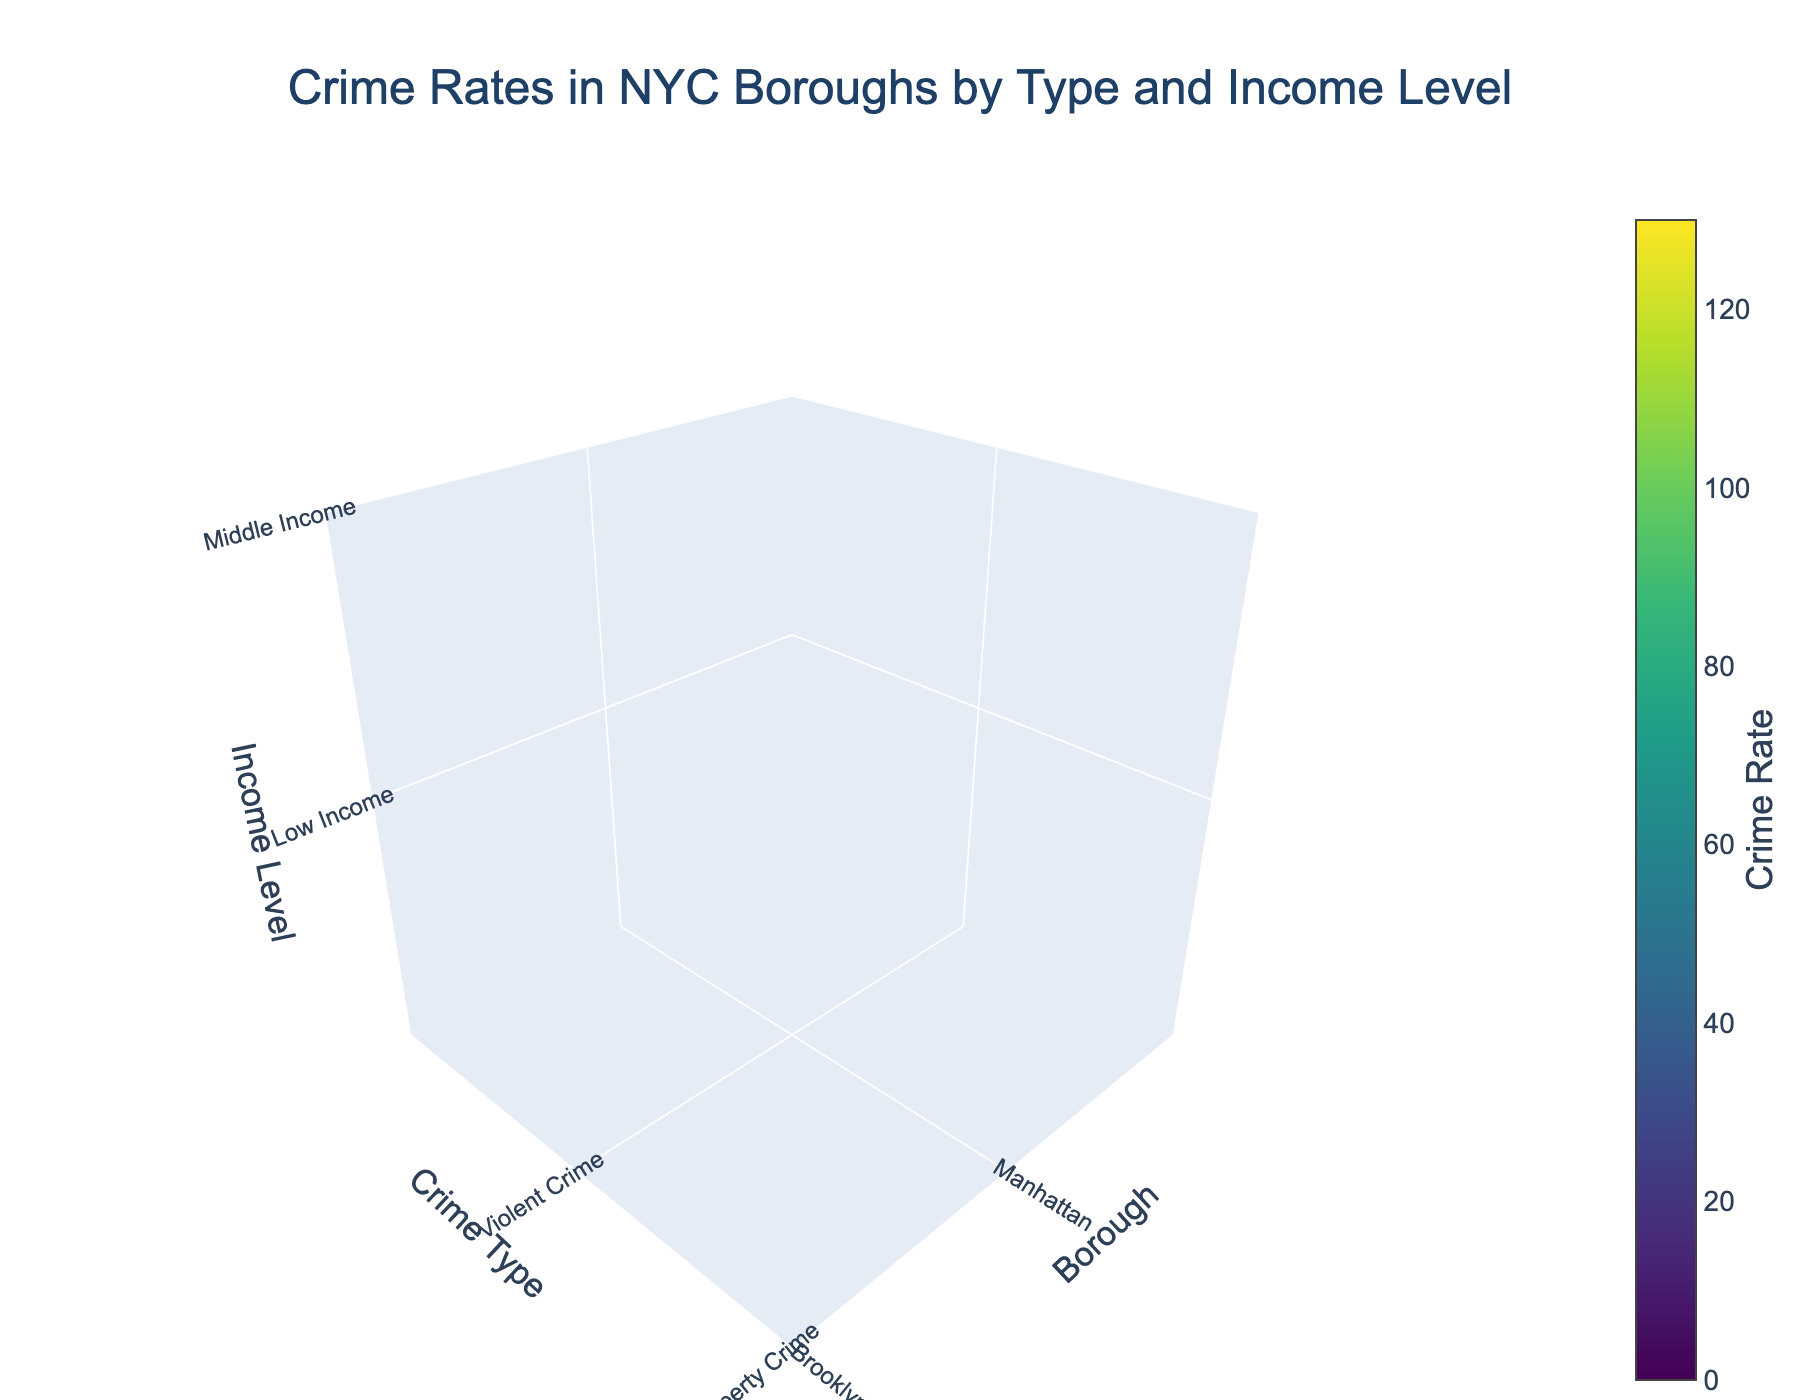Which borough has the highest violent crime rate in low-income areas? To find the borough with the highest violent crime rate in low-income areas, locate the intersection of "Violent Crime" and "Low Income" on the income level axis. The highest value at this point is associated with the Bronx.
Answer: Bronx What is the total property crime rate in Queens across all income levels? Add the property crime rates for Queens in low-income (100), middle-income (80), and high-income (65) areas. The total is 100 + 80 + 65.
Answer: 245 Which income level has the lowest violent crime rate in Brooklyn? Compare the violent crime rates for Brooklyn across low-income (95), middle-income (55), and high-income (25) levels. The lowest rate is found in the high-income level.
Answer: High Income How does the property crime rate in middle-income areas of Manhattan compare to high-income areas of the same borough? Look at the property crime rates in Manhattan for middle-income (95) and high-income (75) areas. The property crime rate is higher in middle-income areas.
Answer: Middle Income is higher What is the average violent crime rate in middle-income areas across all boroughs? Calculate the average by adding the violent crime rates for middle-income areas in Manhattan (45), Brooklyn (55), Queens (40), and the Bronx (60), then divide by the number of boroughs (4). (45 + 55 + 40 + 60) / 4 = 200 / 4.
Answer: 50 In which borough is the disparity between property and violent crime rates highest in low-income areas? Calculate the differences between property and violent crime rates in low-income areas for Manhattan (120-85=35), Brooklyn (110-95=15), Queens (100-75=25), and the Bronx (130-105=25). The largest disparity is in Manhattan.
Answer: Manhattan Considering high-income areas, does any borough have a lower violent crime rate compared to property crime rate? Compare the violent and property crime rates in high-income areas for each borough. All high-income violent crime rates (Manhattan 20, Brooklyn 25, Queens 15, Bronx 30) are lower than their respective property crime rates (Manhattan 75, Brooklyn 70, Queens 65, Bronx 70).
Answer: All boroughs What is the total crime rate (both violent and property) in the Bronx for high-income areas? Sum the violent (30) and property (70) crime rates for high-income areas in the Bronx. The total is 30 + 70.
Answer: 100 Which type of crime generally shows higher rates in low-income areas across all boroughs? Compare the rates of both violent and property crimes in low-income areas across all boroughs. Property crime rates are consistently higher than violent crime rates in all boroughs.
Answer: Property Crime 